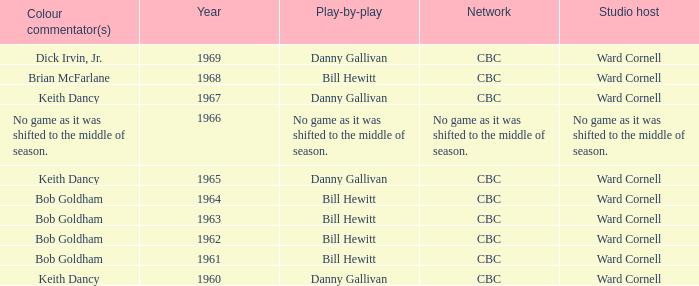Were the color commentators who worked with Bill Hewitt doing the play-by-play? Brian McFarlane, Bob Goldham, Bob Goldham, Bob Goldham, Bob Goldham. 